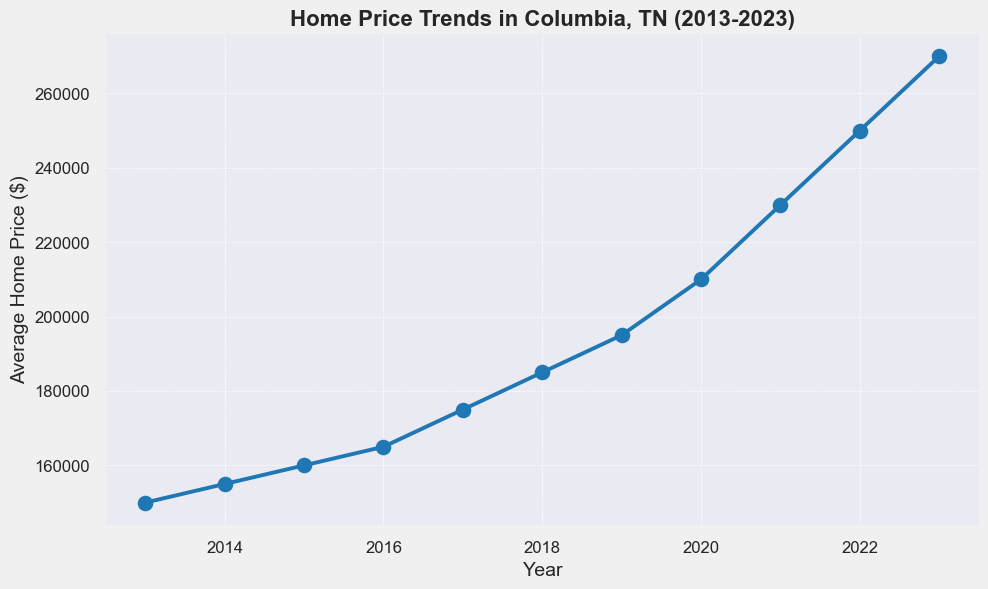What's the difference in average home price between 2013 and 2023? To find the difference, subtract the average home price in 2013 from the average home price in 2023. 270000 - 150000 = 120000
Answer: 120000 Which year experienced the highest increase in average home price compared to the previous year? To determine this, look at the differences between the consecutive years and find the maximum. The yearly increases are: 5000 (2014-2013), 5000 (2015-2014), 5000 (2016-2015), 10000 (2017-2016), 10000 (2018-2017), 10000 (2019-2018), 15000 (2020-2019), 20000 (2021-2020), 20000 (2022-2021), and 20000 (2023-2022). The highest increase is 20000 and occurs in 2021, 2022, and 2023.
Answer: 2021, 2022, 2023 What is the average increase in home price per year over the 10-year period? To find the average yearly increase, subtract the 2013 price from the 2023 price and divide by the number of years. (270000 - 150000) / (2023 - 2013) = 120000 / 10 = 12000
Answer: 12000 How much more expensive was the average home price in 2020 compared to 2018? Subtract the average home price in 2018 from the average home price in 2020 to find the difference. 210000 - 185000 = 25000
Answer: 25000 Between which two consecutive years did the home price increase by $20,000 for the first time? Reference the differences between consecutive years. The first occurrence is between 2020 and 2021. The increase is 230000 - 210000 = 20000
Answer: 2020 and 2021 From the chart's visual attributes, in which year did the average home price change least compared to the previous year? By comparing the slopes of the line segments, the smallest change visually appears between 2013 and 2014, 2014 and 2015, and 2015 and 2016, as their increases are all $5000.
Answer: 2013 to 2014, 2014 to 2015, 2015 to 2016 Which period shows a consistent increase in home prices each year visually? From 2013 to 2019, the chart shows a steady increase each year without any decrease.
Answer: 2013 to 2019 